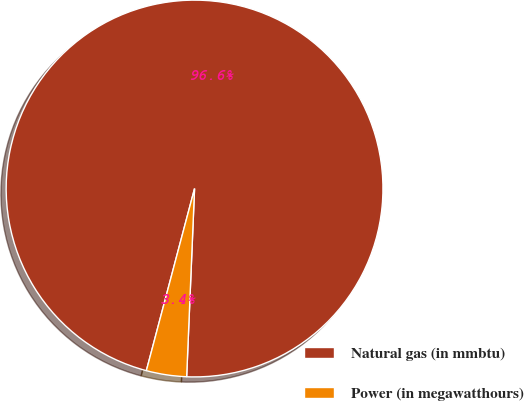Convert chart to OTSL. <chart><loc_0><loc_0><loc_500><loc_500><pie_chart><fcel>Natural gas (in mmbtu)<fcel>Power (in megawatthours)<nl><fcel>96.55%<fcel>3.45%<nl></chart> 